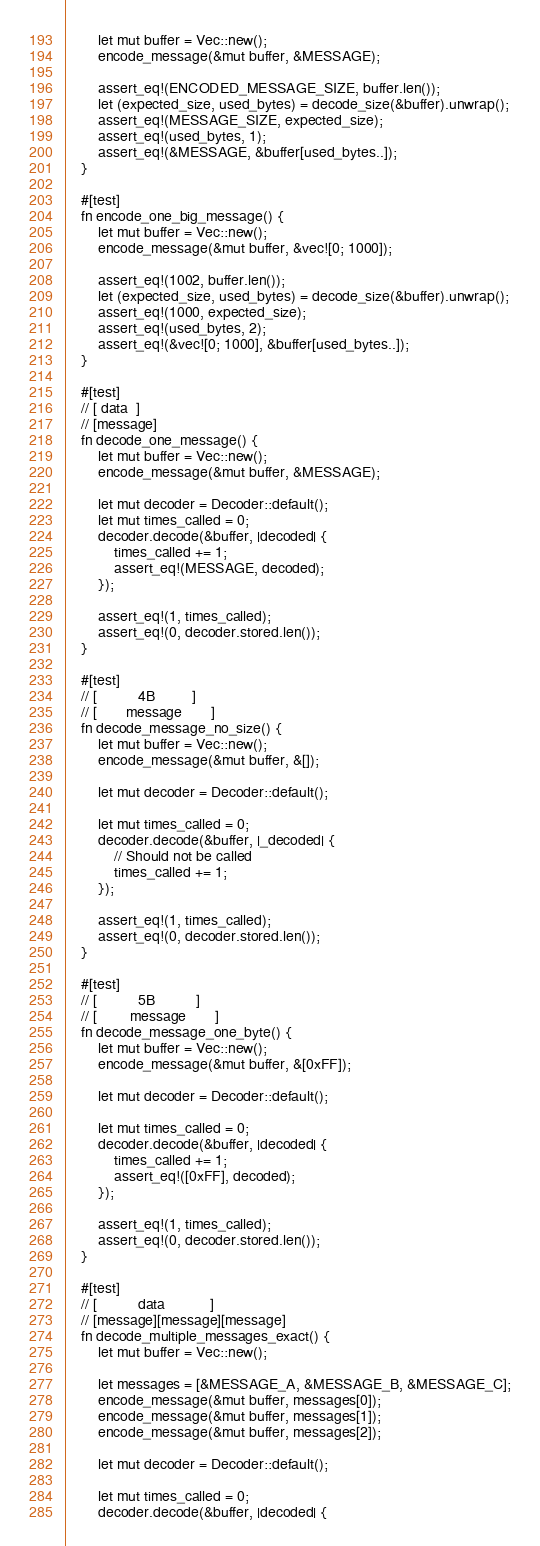Convert code to text. <code><loc_0><loc_0><loc_500><loc_500><_Rust_>        let mut buffer = Vec::new();
        encode_message(&mut buffer, &MESSAGE);

        assert_eq!(ENCODED_MESSAGE_SIZE, buffer.len());
        let (expected_size, used_bytes) = decode_size(&buffer).unwrap();
        assert_eq!(MESSAGE_SIZE, expected_size);
        assert_eq!(used_bytes, 1);
        assert_eq!(&MESSAGE, &buffer[used_bytes..]);
    }

    #[test]
    fn encode_one_big_message() {
        let mut buffer = Vec::new();
        encode_message(&mut buffer, &vec![0; 1000]);

        assert_eq!(1002, buffer.len());
        let (expected_size, used_bytes) = decode_size(&buffer).unwrap();
        assert_eq!(1000, expected_size);
        assert_eq!(used_bytes, 2);
        assert_eq!(&vec![0; 1000], &buffer[used_bytes..]);
    }

    #[test]
    // [ data  ]
    // [message]
    fn decode_one_message() {
        let mut buffer = Vec::new();
        encode_message(&mut buffer, &MESSAGE);

        let mut decoder = Decoder::default();
        let mut times_called = 0;
        decoder.decode(&buffer, |decoded| {
            times_called += 1;
            assert_eq!(MESSAGE, decoded);
        });

        assert_eq!(1, times_called);
        assert_eq!(0, decoder.stored.len());
    }

    #[test]
    // [          4B         ]
    // [       message       ]
    fn decode_message_no_size() {
        let mut buffer = Vec::new();
        encode_message(&mut buffer, &[]);

        let mut decoder = Decoder::default();

        let mut times_called = 0;
        decoder.decode(&buffer, |_decoded| {
            // Should not be called
            times_called += 1;
        });

        assert_eq!(1, times_called);
        assert_eq!(0, decoder.stored.len());
    }

    #[test]
    // [          5B          ]
    // [        message       ]
    fn decode_message_one_byte() {
        let mut buffer = Vec::new();
        encode_message(&mut buffer, &[0xFF]);

        let mut decoder = Decoder::default();

        let mut times_called = 0;
        decoder.decode(&buffer, |decoded| {
            times_called += 1;
            assert_eq!([0xFF], decoded);
        });

        assert_eq!(1, times_called);
        assert_eq!(0, decoder.stored.len());
    }

    #[test]
    // [          data           ]
    // [message][message][message]
    fn decode_multiple_messages_exact() {
        let mut buffer = Vec::new();

        let messages = [&MESSAGE_A, &MESSAGE_B, &MESSAGE_C];
        encode_message(&mut buffer, messages[0]);
        encode_message(&mut buffer, messages[1]);
        encode_message(&mut buffer, messages[2]);

        let mut decoder = Decoder::default();

        let mut times_called = 0;
        decoder.decode(&buffer, |decoded| {</code> 